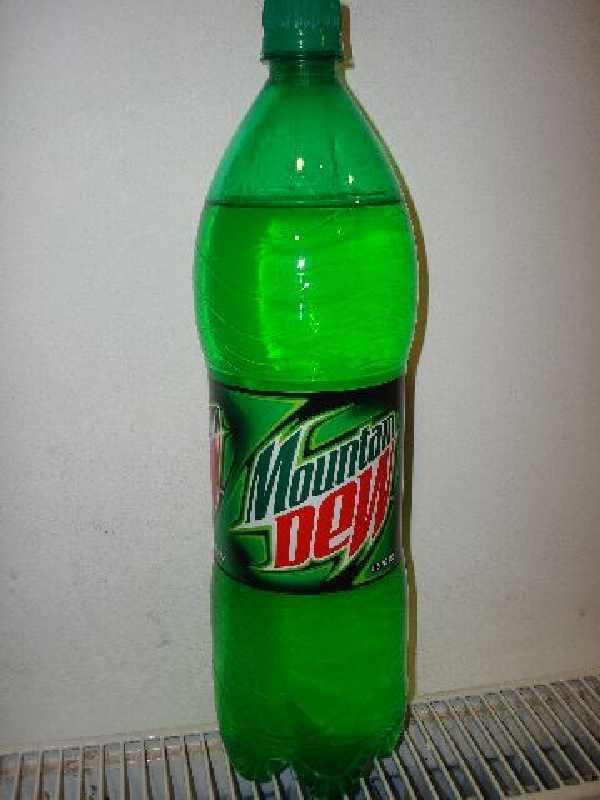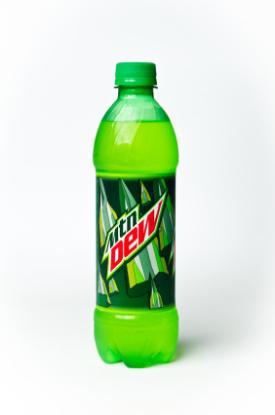The first image is the image on the left, the second image is the image on the right. Examine the images to the left and right. Is the description "None of the bottles are capped." accurate? Answer yes or no. No. The first image is the image on the left, the second image is the image on the right. Assess this claim about the two images: "An equal number of soda bottles are in each image, all the same brand, but with different labeling in view.". Correct or not? Answer yes or no. Yes. 